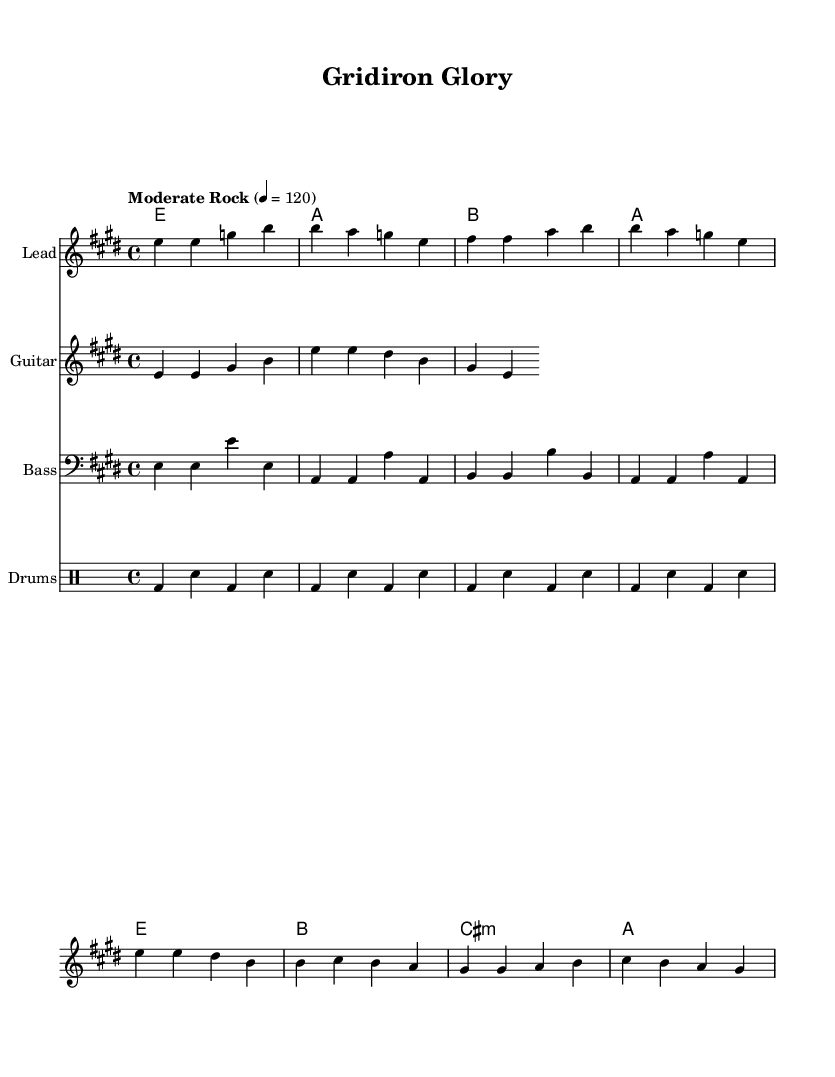What is the key signature of this music? The key signature is E major, which has four sharps (F#, C#, G#, D#).
Answer: E major What is the time signature of this music? The time signature is 4/4, meaning there are four beats per measure and a quarter note receives one beat.
Answer: 4/4 What is the tempo marking for this piece? The tempo marking is "Moderate Rock," indicating a moderate pace suitable for a rock style.
Answer: Moderate Rock How many measures are in the verse section? The verse section consists of four measures, as indicated by the grouping of notes.
Answer: 4 What chords are used in the chorus? The chords used in the chorus are E, B, C# minor, and A, as indicated in the chord section of the sheet music.
Answer: E, B, C# minor, A What is the instrumentation for this piece? The instrumentation includes Lead, Guitar, Bass, and Drums, as specified in the score layout.
Answer: Lead, Guitar, Bass, Drums How does the lyrical theme relate to teamwork? The lyrics emphasize unity and perseverance, focusing on facing challenges together, which reflects the essence of teamwork.
Answer: Unity and perseverance 